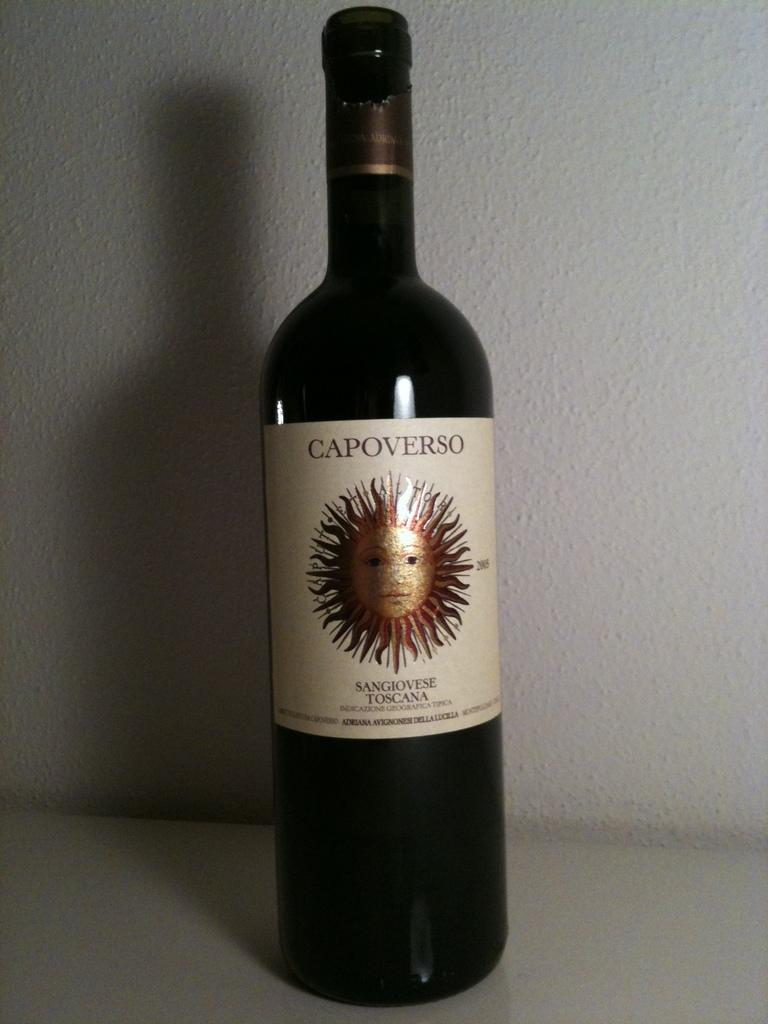<image>
Give a short and clear explanation of the subsequent image. A single bottle of Capoverso sitting near a white wall. 